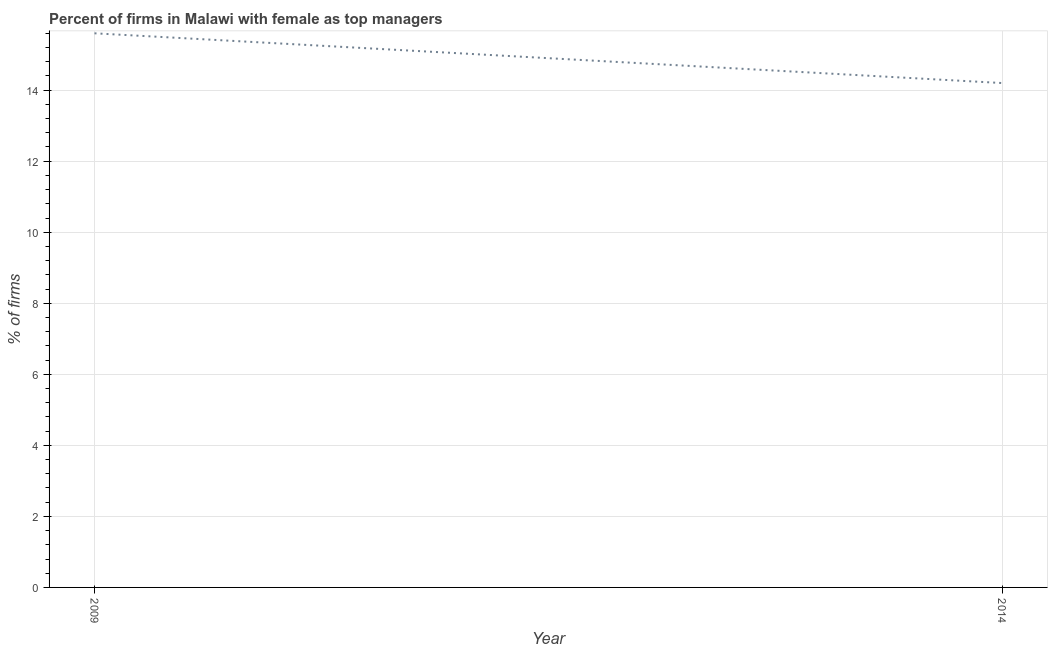Across all years, what is the minimum percentage of firms with female as top manager?
Provide a succinct answer. 14.2. In which year was the percentage of firms with female as top manager maximum?
Your answer should be very brief. 2009. In which year was the percentage of firms with female as top manager minimum?
Your response must be concise. 2014. What is the sum of the percentage of firms with female as top manager?
Ensure brevity in your answer.  29.8. What is the difference between the percentage of firms with female as top manager in 2009 and 2014?
Offer a terse response. 1.4. What is the average percentage of firms with female as top manager per year?
Give a very brief answer. 14.9. What is the median percentage of firms with female as top manager?
Offer a very short reply. 14.9. In how many years, is the percentage of firms with female as top manager greater than 5.2 %?
Offer a very short reply. 2. What is the ratio of the percentage of firms with female as top manager in 2009 to that in 2014?
Offer a very short reply. 1.1. Does the percentage of firms with female as top manager monotonically increase over the years?
Ensure brevity in your answer.  No. How many lines are there?
Your answer should be compact. 1. Does the graph contain any zero values?
Your answer should be very brief. No. What is the title of the graph?
Give a very brief answer. Percent of firms in Malawi with female as top managers. What is the label or title of the Y-axis?
Ensure brevity in your answer.  % of firms. What is the % of firms of 2014?
Ensure brevity in your answer.  14.2. What is the difference between the % of firms in 2009 and 2014?
Keep it short and to the point. 1.4. What is the ratio of the % of firms in 2009 to that in 2014?
Your answer should be compact. 1.1. 